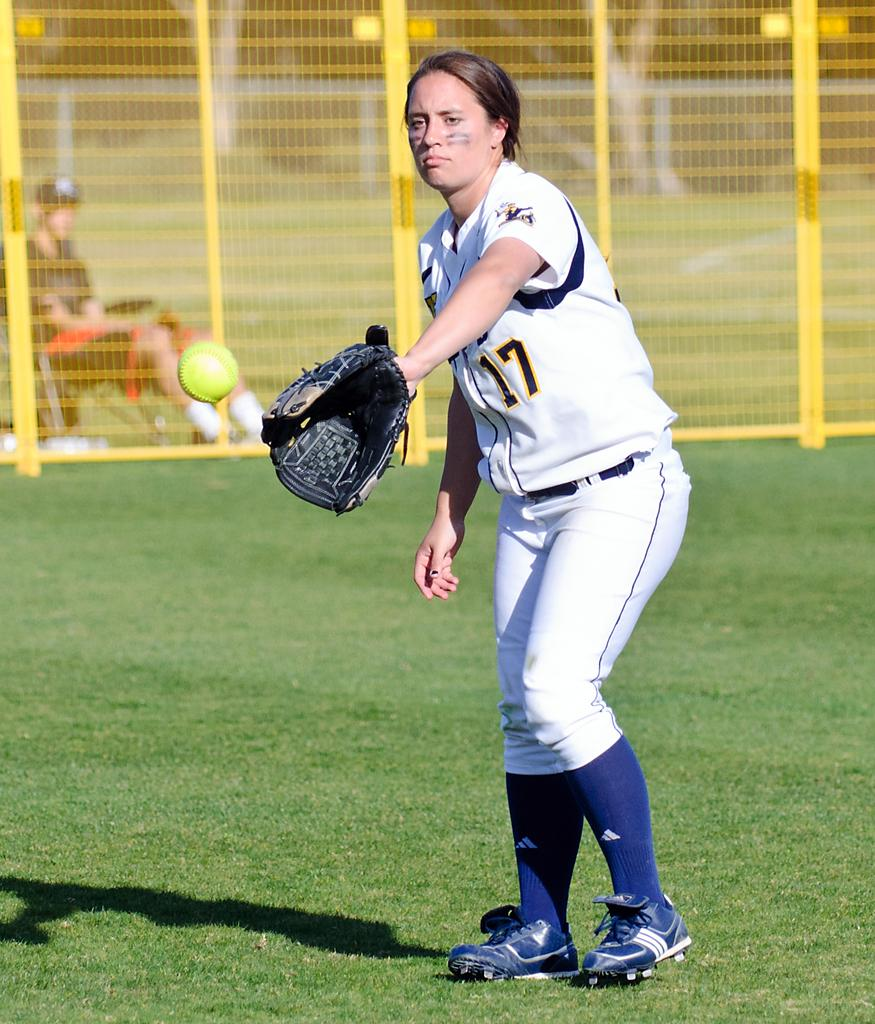<image>
Offer a succinct explanation of the picture presented. A female baseball player with the number 17 on her shirt is posing with her mitt. 